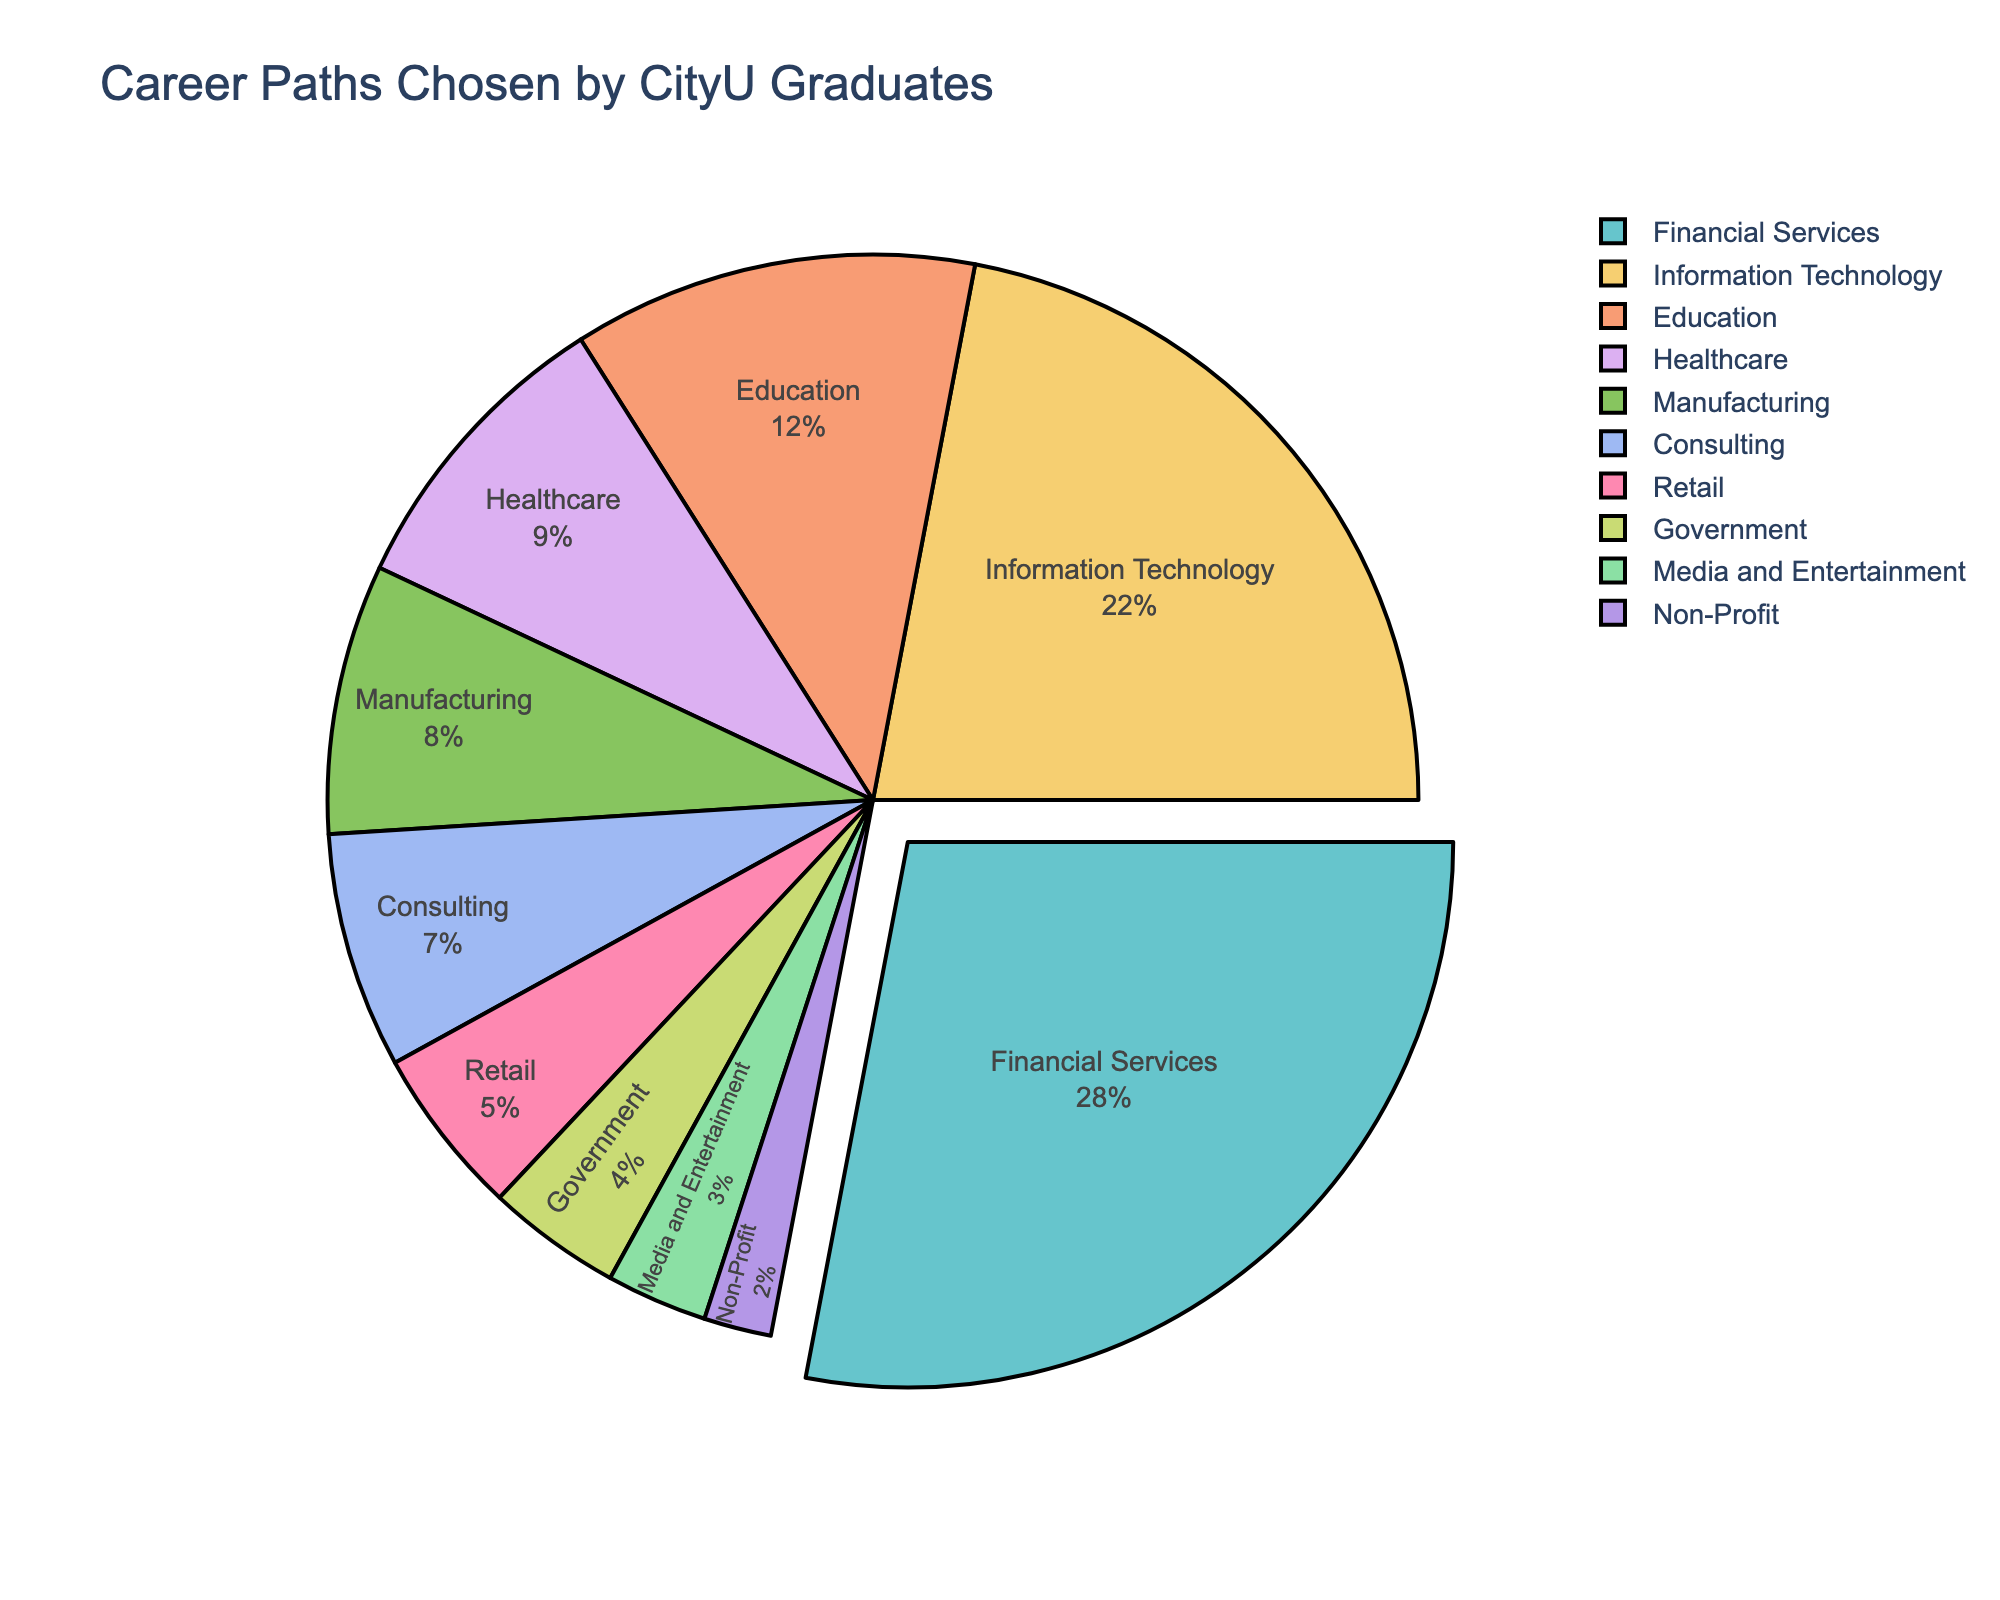Which industry has the highest percentage of CityU graduates? By referring to the figure, one can observe which industry sector occupies the largest section of the pie chart. The largest section corresponds to Financial Services, which is indicated by the largest percentage.
Answer: Financial Services What is the combined percentage of graduates in Financial Services, Information Technology, and Education? To find this, add the percentages for Financial Services (28%), Information Technology (22%), and Education (12%). The combined percentage is 28 + 22 + 12 = 62%.
Answer: 62% Which sector has a slightly larger percentage, Healthcare or Manufacturing? By comparing the sections of the pie chart for Healthcare and Manufacturing, it is evident that Healthcare is 9% while Manufacturing is 8%. Therefore, Healthcare has a slightly larger percentage.
Answer: Healthcare How does the percentage of graduates in Consulting compare to those in Government? By examining the pie chart, Consulting has a section marked with 7%, whereas Government has a section marked with 4%. Hence, Consulting has a higher percentage of graduates compared to Government.
Answer: Consulting What is the total percentage of graduates working in sectors other than Financial Services and Information Technology? To find the total percentage of graduates in other sectors, subtract the sum of Financial Services (28%) and Information Technology (22%) from 100%. This is 100 - 28 - 22 = 50%.
Answer: 50% What is the difference in percentages between the Graduates in Retail and Non-Profit sectors? The percentage for Retail is 5% and for Non-Profit is 2%. Subtract the Non-Profit percentage from Retail’s: 5 - 2 = 3%.
Answer: 3% Is the number of graduates in Media and Entertainment higher or lower than those in Education? According to the pie chart, Education has 12% while Media and Entertainment has 3%, meaning that the percentage of graduates in Media and Entertainment is lower than those in Education.
Answer: Lower Which sectors combined make up a quarter of the graduates? Calculate the combined percentages of sectors until they sum to 25%. Non-Profit (2%) + Media and Entertainment (3%) + Government (4%) = 9%. Adding Retail (5%) results in 14%. Adding Consulting (7%) results in 21%. Adding Manufacturing (8%) results in 29%. Since Consulting plus Healthcare would result in more than 25%, it's necessary to check various combinations to find the most fitting one, but no exact combination adds to exactly 25%. Here, Retail (5%) + Consulting (7%) + Manufacturing (8%) + Non-Profit (2%) = 22% is close and the most valid combination.
Answer: Retail, Consulting, Manufacturing, Non-Profit What is the combined percentage of Media and Entertainment and Non-Profit sectors? Add the percentages for Media and Entertainment (3%) and Non-Profit (2%) by referring to the pie chart: hence, the sum is 3 + 2 = 5%.
Answer: 5% Compare the percentage of graduates in Healthcare with that in Information Technology. Which is larger and by how much? The Healthcare sector has 9% of graduates whereas Information Technology has 22%. Subtract the percentage of Healthcare from Information Technology: 22 - 9 = 13%.
Answer: Information Technology, 13% 